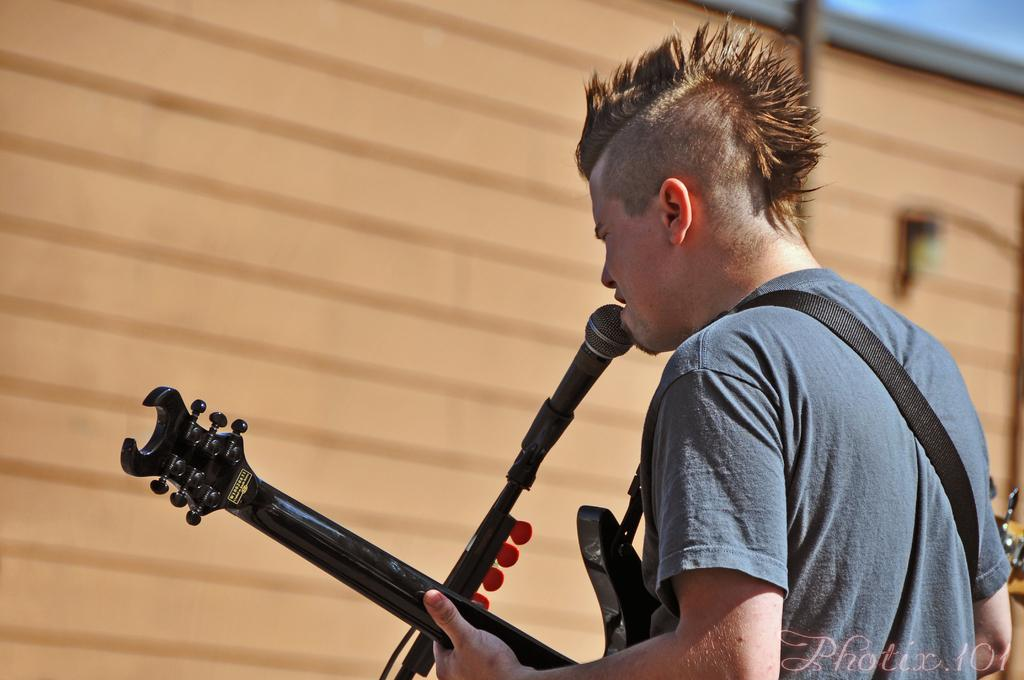Who is the main subject in the image? There is a man in the image. What is the man holding in the image? The man is holding a guitar. What object is in front of the man? There is a microphone in front of the man. What color is the t-shirt the man is wearing? The man is wearing a blue color t-shirt. How many boys are playing with trains in the image? There are no boys or trains present in the image. What word is written on the stop sign in the image? There is no stop sign present in the image. 